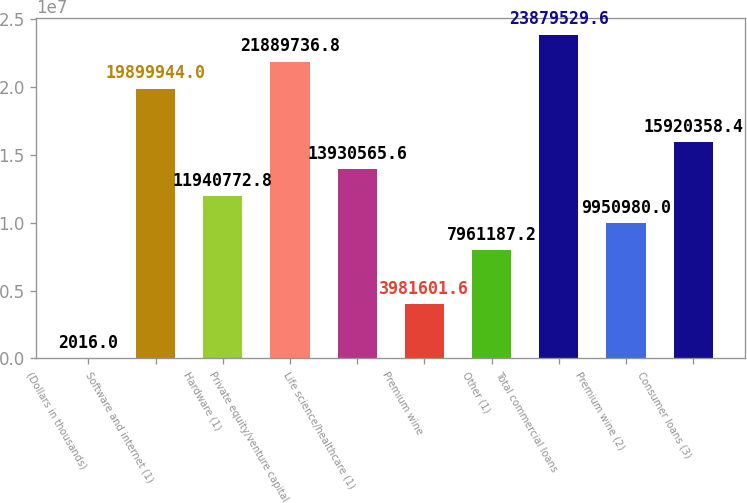<chart> <loc_0><loc_0><loc_500><loc_500><bar_chart><fcel>(Dollars in thousands)<fcel>Software and internet (1)<fcel>Hardware (1)<fcel>Private equity/venture capital<fcel>Life science/healthcare (1)<fcel>Premium wine<fcel>Other (1)<fcel>Total commercial loans<fcel>Premium wine (2)<fcel>Consumer loans (3)<nl><fcel>2016<fcel>1.98999e+07<fcel>1.19408e+07<fcel>2.18897e+07<fcel>1.39306e+07<fcel>3.9816e+06<fcel>7.96119e+06<fcel>2.38795e+07<fcel>9.95098e+06<fcel>1.59204e+07<nl></chart> 